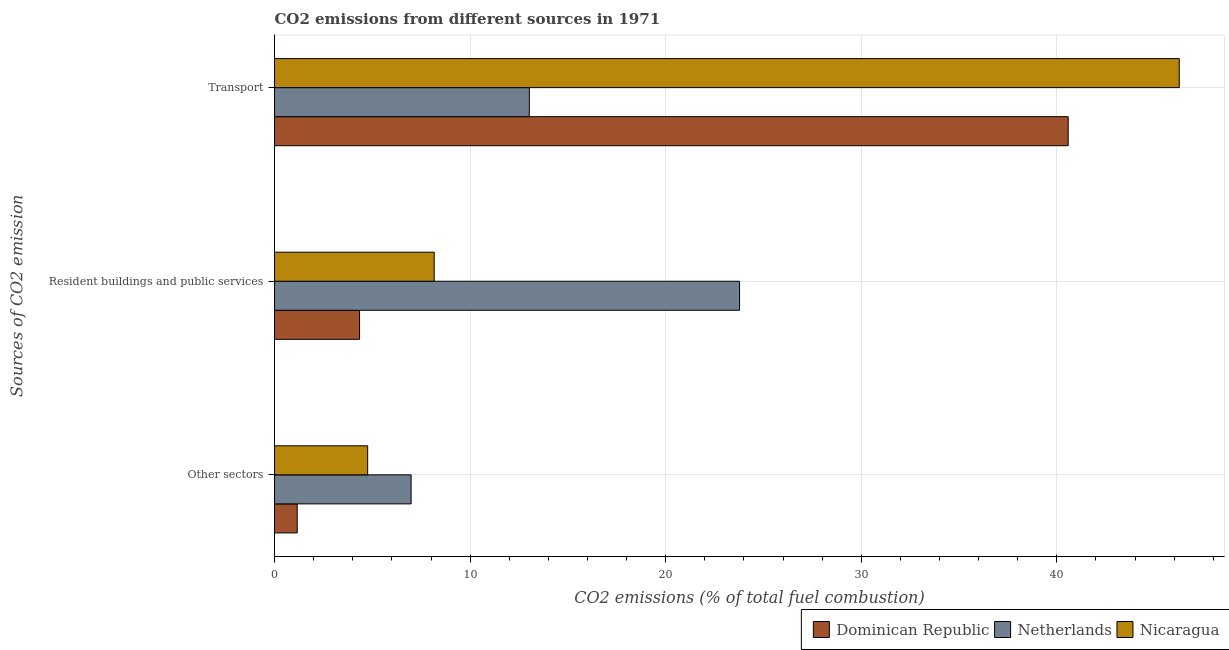How many different coloured bars are there?
Keep it short and to the point. 3. How many groups of bars are there?
Make the answer very short. 3. How many bars are there on the 3rd tick from the top?
Your answer should be compact. 3. How many bars are there on the 1st tick from the bottom?
Your answer should be compact. 3. What is the label of the 1st group of bars from the top?
Keep it short and to the point. Transport. What is the percentage of co2 emissions from resident buildings and public services in Nicaragua?
Make the answer very short. 8.16. Across all countries, what is the maximum percentage of co2 emissions from resident buildings and public services?
Offer a terse response. 23.78. Across all countries, what is the minimum percentage of co2 emissions from other sectors?
Make the answer very short. 1.16. In which country was the percentage of co2 emissions from other sectors maximum?
Your answer should be compact. Netherlands. What is the total percentage of co2 emissions from transport in the graph?
Provide a short and direct response. 99.86. What is the difference between the percentage of co2 emissions from transport in Dominican Republic and that in Nicaragua?
Your answer should be very brief. -5.68. What is the difference between the percentage of co2 emissions from resident buildings and public services in Nicaragua and the percentage of co2 emissions from other sectors in Netherlands?
Provide a short and direct response. 1.18. What is the average percentage of co2 emissions from resident buildings and public services per country?
Ensure brevity in your answer.  12.1. What is the difference between the percentage of co2 emissions from other sectors and percentage of co2 emissions from resident buildings and public services in Dominican Republic?
Ensure brevity in your answer.  -3.19. In how many countries, is the percentage of co2 emissions from other sectors greater than 34 %?
Your answer should be very brief. 0. What is the ratio of the percentage of co2 emissions from other sectors in Dominican Republic to that in Nicaragua?
Your response must be concise. 0.24. What is the difference between the highest and the second highest percentage of co2 emissions from transport?
Your answer should be compact. 5.68. What is the difference between the highest and the lowest percentage of co2 emissions from transport?
Offer a terse response. 33.23. In how many countries, is the percentage of co2 emissions from transport greater than the average percentage of co2 emissions from transport taken over all countries?
Provide a short and direct response. 2. What does the 3rd bar from the top in Transport represents?
Offer a terse response. Dominican Republic. What does the 3rd bar from the bottom in Resident buildings and public services represents?
Keep it short and to the point. Nicaragua. Is it the case that in every country, the sum of the percentage of co2 emissions from other sectors and percentage of co2 emissions from resident buildings and public services is greater than the percentage of co2 emissions from transport?
Make the answer very short. No. Are all the bars in the graph horizontal?
Give a very brief answer. Yes. How many countries are there in the graph?
Make the answer very short. 3. What is the difference between two consecutive major ticks on the X-axis?
Offer a very short reply. 10. Are the values on the major ticks of X-axis written in scientific E-notation?
Offer a terse response. No. Does the graph contain any zero values?
Provide a short and direct response. No. Does the graph contain grids?
Your response must be concise. Yes. What is the title of the graph?
Ensure brevity in your answer.  CO2 emissions from different sources in 1971. What is the label or title of the X-axis?
Offer a very short reply. CO2 emissions (% of total fuel combustion). What is the label or title of the Y-axis?
Give a very brief answer. Sources of CO2 emission. What is the CO2 emissions (% of total fuel combustion) of Dominican Republic in Other sectors?
Provide a succinct answer. 1.16. What is the CO2 emissions (% of total fuel combustion) of Netherlands in Other sectors?
Provide a succinct answer. 6.98. What is the CO2 emissions (% of total fuel combustion) of Nicaragua in Other sectors?
Provide a short and direct response. 4.76. What is the CO2 emissions (% of total fuel combustion) of Dominican Republic in Resident buildings and public services?
Ensure brevity in your answer.  4.35. What is the CO2 emissions (% of total fuel combustion) of Netherlands in Resident buildings and public services?
Make the answer very short. 23.78. What is the CO2 emissions (% of total fuel combustion) in Nicaragua in Resident buildings and public services?
Your answer should be very brief. 8.16. What is the CO2 emissions (% of total fuel combustion) in Dominican Republic in Transport?
Your response must be concise. 40.58. What is the CO2 emissions (% of total fuel combustion) in Netherlands in Transport?
Your answer should be compact. 13.03. What is the CO2 emissions (% of total fuel combustion) of Nicaragua in Transport?
Offer a very short reply. 46.26. Across all Sources of CO2 emission, what is the maximum CO2 emissions (% of total fuel combustion) in Dominican Republic?
Your response must be concise. 40.58. Across all Sources of CO2 emission, what is the maximum CO2 emissions (% of total fuel combustion) of Netherlands?
Your answer should be very brief. 23.78. Across all Sources of CO2 emission, what is the maximum CO2 emissions (% of total fuel combustion) of Nicaragua?
Your answer should be compact. 46.26. Across all Sources of CO2 emission, what is the minimum CO2 emissions (% of total fuel combustion) in Dominican Republic?
Ensure brevity in your answer.  1.16. Across all Sources of CO2 emission, what is the minimum CO2 emissions (% of total fuel combustion) of Netherlands?
Provide a short and direct response. 6.98. Across all Sources of CO2 emission, what is the minimum CO2 emissions (% of total fuel combustion) of Nicaragua?
Provide a short and direct response. 4.76. What is the total CO2 emissions (% of total fuel combustion) in Dominican Republic in the graph?
Ensure brevity in your answer.  46.09. What is the total CO2 emissions (% of total fuel combustion) in Netherlands in the graph?
Your answer should be compact. 43.79. What is the total CO2 emissions (% of total fuel combustion) of Nicaragua in the graph?
Give a very brief answer. 59.18. What is the difference between the CO2 emissions (% of total fuel combustion) in Dominican Republic in Other sectors and that in Resident buildings and public services?
Give a very brief answer. -3.19. What is the difference between the CO2 emissions (% of total fuel combustion) of Netherlands in Other sectors and that in Resident buildings and public services?
Your response must be concise. -16.79. What is the difference between the CO2 emissions (% of total fuel combustion) of Nicaragua in Other sectors and that in Resident buildings and public services?
Offer a very short reply. -3.4. What is the difference between the CO2 emissions (% of total fuel combustion) of Dominican Republic in Other sectors and that in Transport?
Provide a succinct answer. -39.42. What is the difference between the CO2 emissions (% of total fuel combustion) in Netherlands in Other sectors and that in Transport?
Offer a terse response. -6.04. What is the difference between the CO2 emissions (% of total fuel combustion) in Nicaragua in Other sectors and that in Transport?
Give a very brief answer. -41.5. What is the difference between the CO2 emissions (% of total fuel combustion) of Dominican Republic in Resident buildings and public services and that in Transport?
Offer a terse response. -36.23. What is the difference between the CO2 emissions (% of total fuel combustion) of Netherlands in Resident buildings and public services and that in Transport?
Your response must be concise. 10.75. What is the difference between the CO2 emissions (% of total fuel combustion) in Nicaragua in Resident buildings and public services and that in Transport?
Make the answer very short. -38.1. What is the difference between the CO2 emissions (% of total fuel combustion) of Dominican Republic in Other sectors and the CO2 emissions (% of total fuel combustion) of Netherlands in Resident buildings and public services?
Ensure brevity in your answer.  -22.62. What is the difference between the CO2 emissions (% of total fuel combustion) in Dominican Republic in Other sectors and the CO2 emissions (% of total fuel combustion) in Nicaragua in Resident buildings and public services?
Offer a terse response. -7. What is the difference between the CO2 emissions (% of total fuel combustion) of Netherlands in Other sectors and the CO2 emissions (% of total fuel combustion) of Nicaragua in Resident buildings and public services?
Make the answer very short. -1.18. What is the difference between the CO2 emissions (% of total fuel combustion) in Dominican Republic in Other sectors and the CO2 emissions (% of total fuel combustion) in Netherlands in Transport?
Keep it short and to the point. -11.87. What is the difference between the CO2 emissions (% of total fuel combustion) in Dominican Republic in Other sectors and the CO2 emissions (% of total fuel combustion) in Nicaragua in Transport?
Your answer should be compact. -45.1. What is the difference between the CO2 emissions (% of total fuel combustion) of Netherlands in Other sectors and the CO2 emissions (% of total fuel combustion) of Nicaragua in Transport?
Your answer should be compact. -39.27. What is the difference between the CO2 emissions (% of total fuel combustion) of Dominican Republic in Resident buildings and public services and the CO2 emissions (% of total fuel combustion) of Netherlands in Transport?
Offer a very short reply. -8.68. What is the difference between the CO2 emissions (% of total fuel combustion) in Dominican Republic in Resident buildings and public services and the CO2 emissions (% of total fuel combustion) in Nicaragua in Transport?
Provide a short and direct response. -41.91. What is the difference between the CO2 emissions (% of total fuel combustion) of Netherlands in Resident buildings and public services and the CO2 emissions (% of total fuel combustion) of Nicaragua in Transport?
Your answer should be very brief. -22.48. What is the average CO2 emissions (% of total fuel combustion) in Dominican Republic per Sources of CO2 emission?
Make the answer very short. 15.36. What is the average CO2 emissions (% of total fuel combustion) in Netherlands per Sources of CO2 emission?
Make the answer very short. 14.6. What is the average CO2 emissions (% of total fuel combustion) in Nicaragua per Sources of CO2 emission?
Offer a terse response. 19.73. What is the difference between the CO2 emissions (% of total fuel combustion) in Dominican Republic and CO2 emissions (% of total fuel combustion) in Netherlands in Other sectors?
Your answer should be very brief. -5.82. What is the difference between the CO2 emissions (% of total fuel combustion) of Dominican Republic and CO2 emissions (% of total fuel combustion) of Nicaragua in Other sectors?
Ensure brevity in your answer.  -3.6. What is the difference between the CO2 emissions (% of total fuel combustion) in Netherlands and CO2 emissions (% of total fuel combustion) in Nicaragua in Other sectors?
Your answer should be compact. 2.22. What is the difference between the CO2 emissions (% of total fuel combustion) in Dominican Republic and CO2 emissions (% of total fuel combustion) in Netherlands in Resident buildings and public services?
Ensure brevity in your answer.  -19.43. What is the difference between the CO2 emissions (% of total fuel combustion) of Dominican Republic and CO2 emissions (% of total fuel combustion) of Nicaragua in Resident buildings and public services?
Your answer should be very brief. -3.82. What is the difference between the CO2 emissions (% of total fuel combustion) in Netherlands and CO2 emissions (% of total fuel combustion) in Nicaragua in Resident buildings and public services?
Your answer should be very brief. 15.61. What is the difference between the CO2 emissions (% of total fuel combustion) in Dominican Republic and CO2 emissions (% of total fuel combustion) in Netherlands in Transport?
Your response must be concise. 27.55. What is the difference between the CO2 emissions (% of total fuel combustion) in Dominican Republic and CO2 emissions (% of total fuel combustion) in Nicaragua in Transport?
Ensure brevity in your answer.  -5.68. What is the difference between the CO2 emissions (% of total fuel combustion) of Netherlands and CO2 emissions (% of total fuel combustion) of Nicaragua in Transport?
Offer a terse response. -33.23. What is the ratio of the CO2 emissions (% of total fuel combustion) in Dominican Republic in Other sectors to that in Resident buildings and public services?
Provide a short and direct response. 0.27. What is the ratio of the CO2 emissions (% of total fuel combustion) of Netherlands in Other sectors to that in Resident buildings and public services?
Give a very brief answer. 0.29. What is the ratio of the CO2 emissions (% of total fuel combustion) of Nicaragua in Other sectors to that in Resident buildings and public services?
Provide a short and direct response. 0.58. What is the ratio of the CO2 emissions (% of total fuel combustion) in Dominican Republic in Other sectors to that in Transport?
Provide a short and direct response. 0.03. What is the ratio of the CO2 emissions (% of total fuel combustion) in Netherlands in Other sectors to that in Transport?
Your answer should be very brief. 0.54. What is the ratio of the CO2 emissions (% of total fuel combustion) of Nicaragua in Other sectors to that in Transport?
Your response must be concise. 0.1. What is the ratio of the CO2 emissions (% of total fuel combustion) in Dominican Republic in Resident buildings and public services to that in Transport?
Offer a terse response. 0.11. What is the ratio of the CO2 emissions (% of total fuel combustion) in Netherlands in Resident buildings and public services to that in Transport?
Ensure brevity in your answer.  1.83. What is the ratio of the CO2 emissions (% of total fuel combustion) in Nicaragua in Resident buildings and public services to that in Transport?
Offer a terse response. 0.18. What is the difference between the highest and the second highest CO2 emissions (% of total fuel combustion) of Dominican Republic?
Keep it short and to the point. 36.23. What is the difference between the highest and the second highest CO2 emissions (% of total fuel combustion) in Netherlands?
Your answer should be very brief. 10.75. What is the difference between the highest and the second highest CO2 emissions (% of total fuel combustion) in Nicaragua?
Your response must be concise. 38.1. What is the difference between the highest and the lowest CO2 emissions (% of total fuel combustion) of Dominican Republic?
Offer a terse response. 39.42. What is the difference between the highest and the lowest CO2 emissions (% of total fuel combustion) of Netherlands?
Provide a succinct answer. 16.79. What is the difference between the highest and the lowest CO2 emissions (% of total fuel combustion) of Nicaragua?
Your answer should be compact. 41.5. 